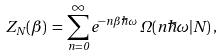<formula> <loc_0><loc_0><loc_500><loc_500>Z _ { N } ( \beta ) \, = \, \sum _ { n = 0 } ^ { \infty } e ^ { - n \beta \hbar { \omega } } \, \Omega ( n \hbar { \omega } | N ) \, ,</formula> 